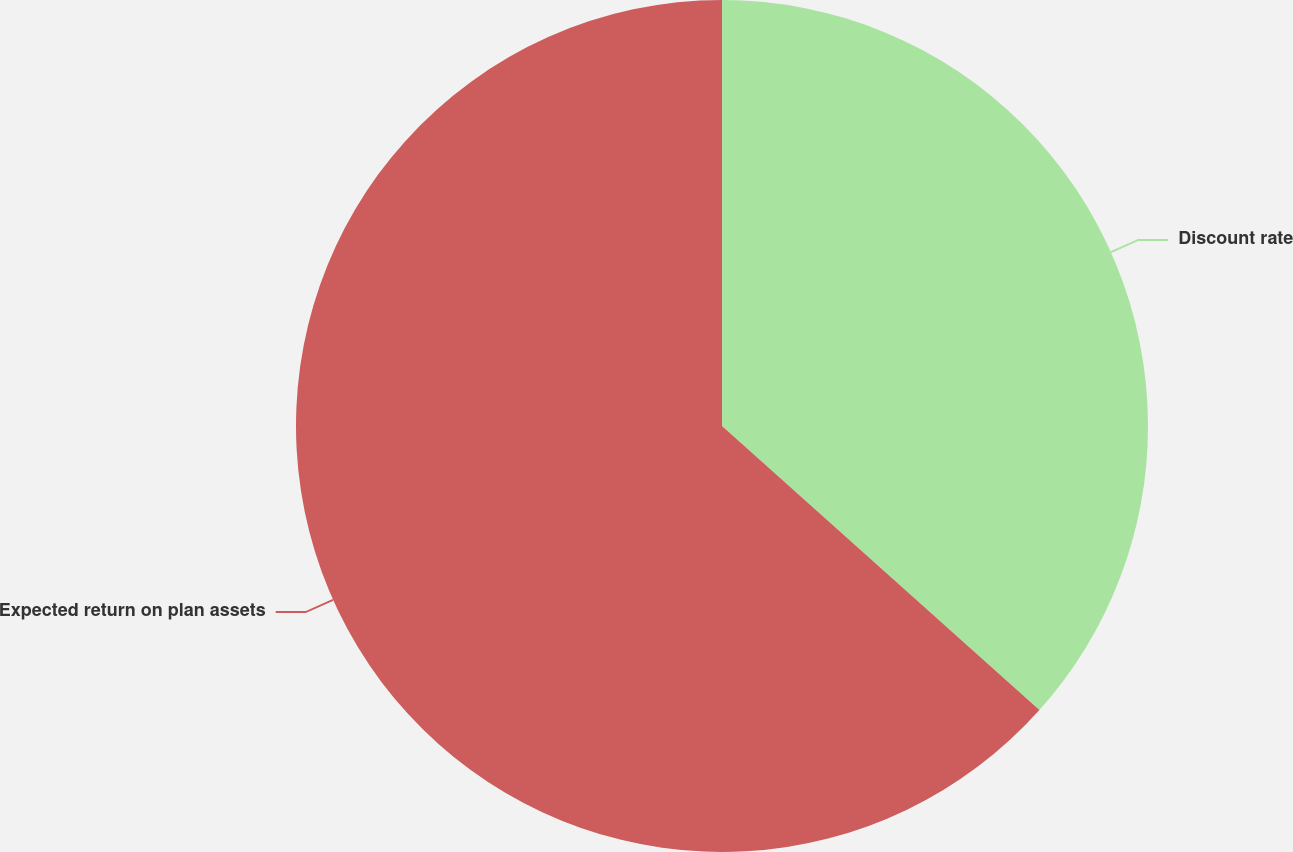Convert chart to OTSL. <chart><loc_0><loc_0><loc_500><loc_500><pie_chart><fcel>Discount rate<fcel>Expected return on plan assets<nl><fcel>36.62%<fcel>63.38%<nl></chart> 